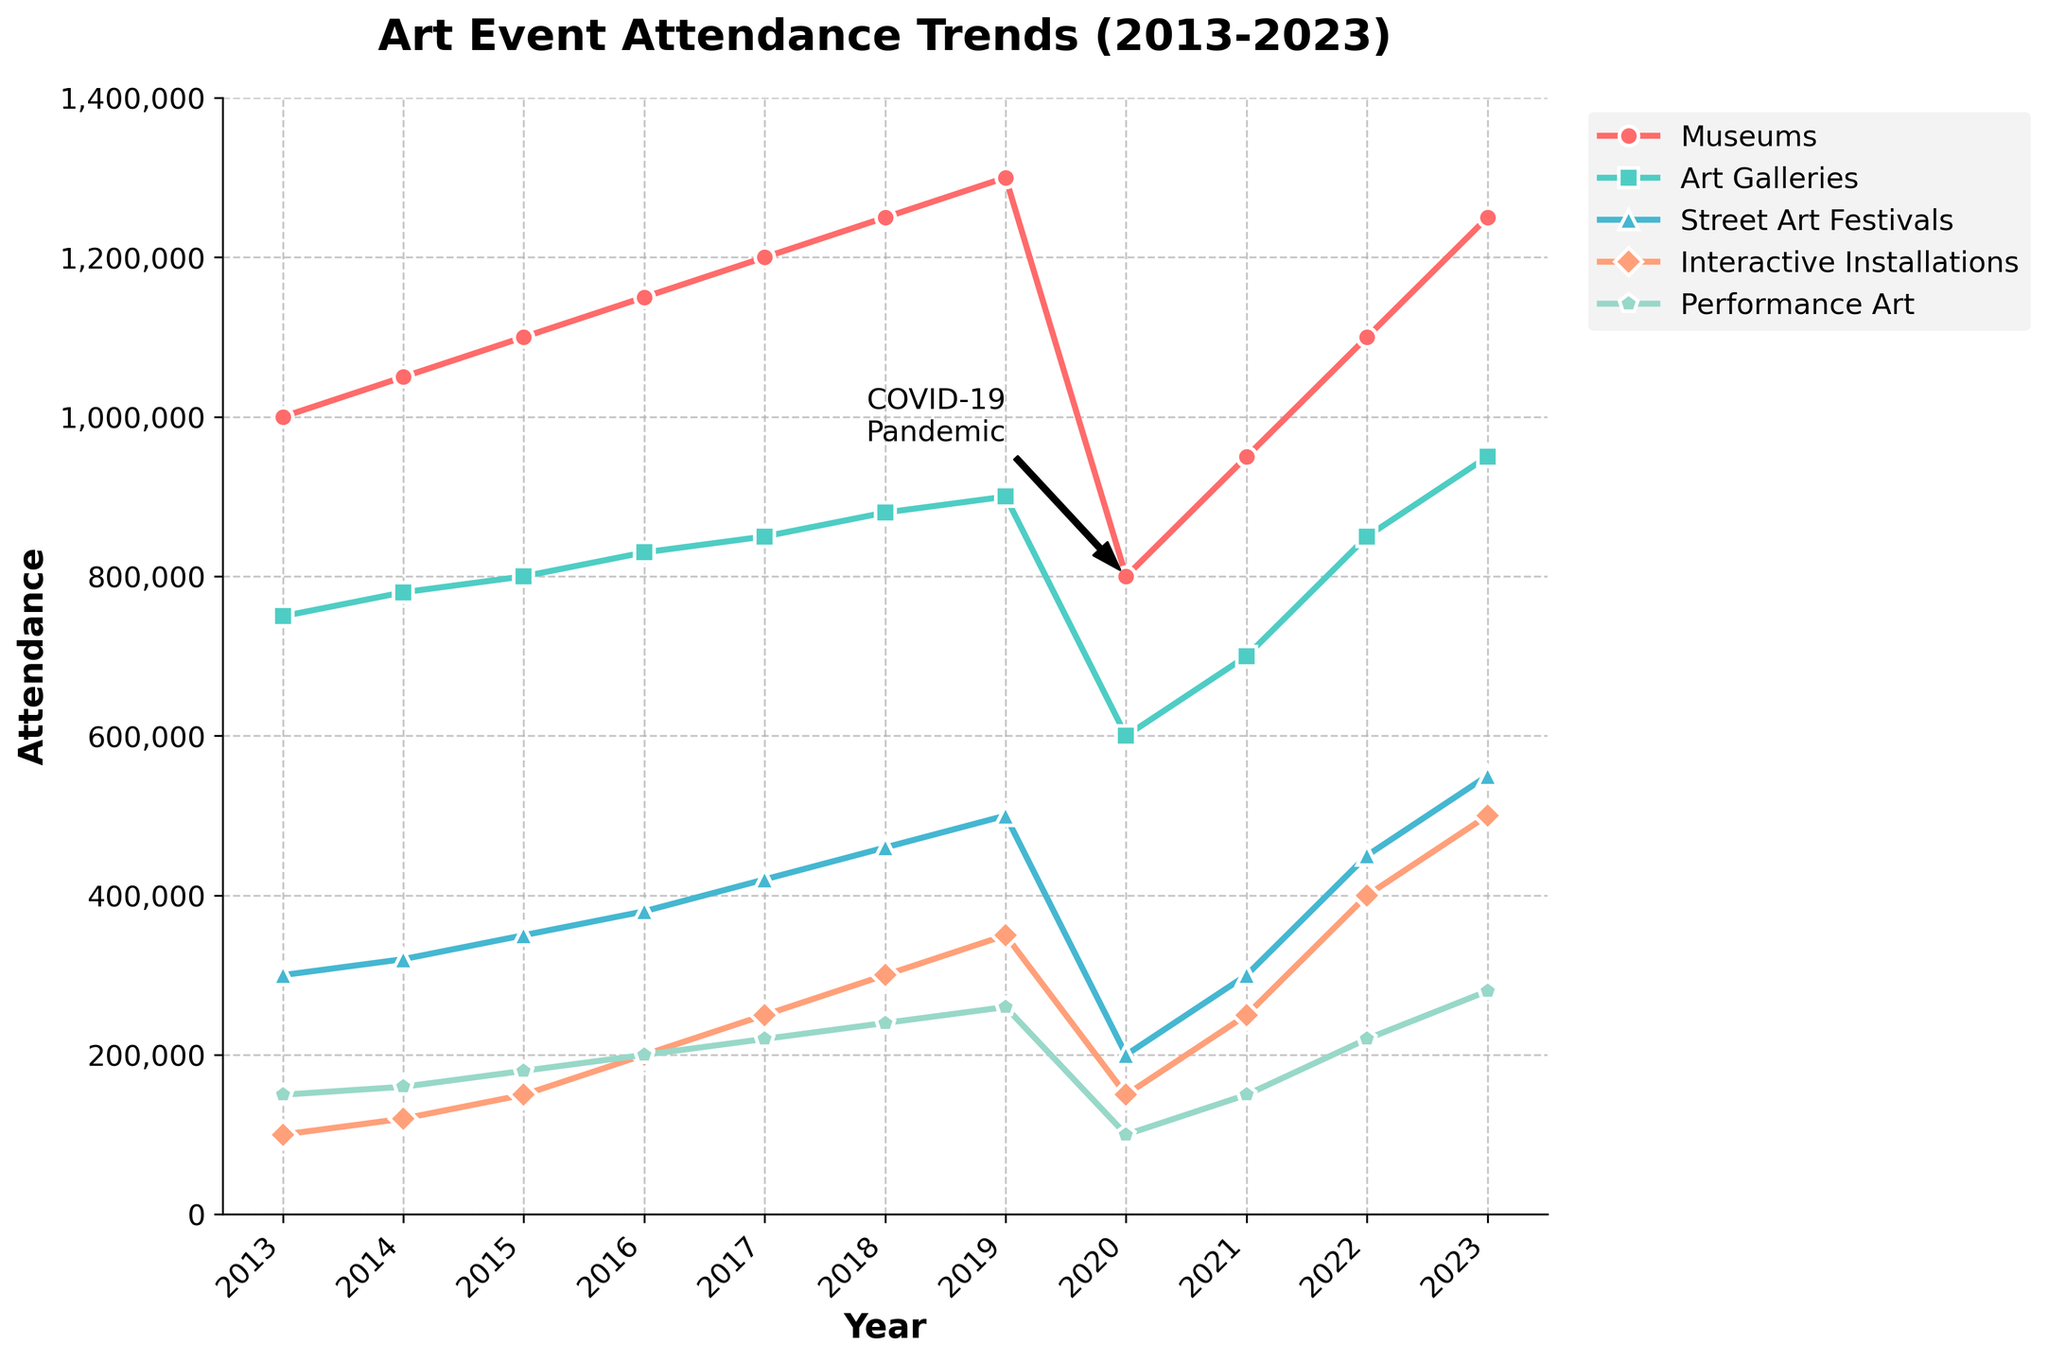What is the overall trend in attendance for Art Galleries from 2013 to 2023? Reviewing the plot reveals that attendance for Art Galleries shows a general upward trend, increasing from 750,000 in 2013 to 950,000 in 2023, with a dip in 2020 due to the COVID-19 pandemic.
Answer: Upward How did the attendance for Interactive Installations change from 2019 to 2023? Observing the plot, attendance for Interactive Installations increased from 350,000 in 2019 to 500,000 in 2023.
Answer: Increased Which event had the highest attendance in 2021? Looking at 2021 on the plot, Museums had the highest attendance with 950,000 attendees.
Answer: Museums Compare the attendance of Performance Art in 2020 and 2023. Observing the plot, Performance Art had 100,000 attendees in 2020 and 280,000 attendees in 2023, reflecting a significant increase over these years.
Answer: 280,000 vs 100,000 During which year did Street Art Festivals reach an attendance of 500,000? Referring to the plot, Street Art Festivals reached 500,000 attendees in the year 2019.
Answer: 2019 Calculate the average attendance for Museums over the given period. Summing up the attendance for Museums from 2013 to 2023 (10,300,000) and dividing by the number of years (11), the average attendance is 10,300,000 / 11 = 936,364.
Answer: 936,364 How did the COVID-19 pandemic affect the attendance across various art events in 2020? The plot shows a significant drop in attendance for all types of art events in 2020 compared to 2019. For example, Museums dropped from 1,300,000 to 800,000.
Answer: Significant drop What's the difference in attendance between the highest and lowest attended art events in 2022? In 2022, Interactive Installations had the highest attendance at 400,000, and Performance Art had the lowest at 220,000. The difference is 400,000 - 220,000 = 180,000.
Answer: 180,000 What color is used to represent the Attendance trend for Street Art Festivals? The plot uses a blue line to depict the attendance trend for Street Art Festivals.
Answer: Blue Which event type showed the least growth from 2013 to 2023? Referring to the plot, Performance Art shows the least growth, starting at 150,000 in 2013 and reaching 280,000 in 2023.
Answer: Performance Art 